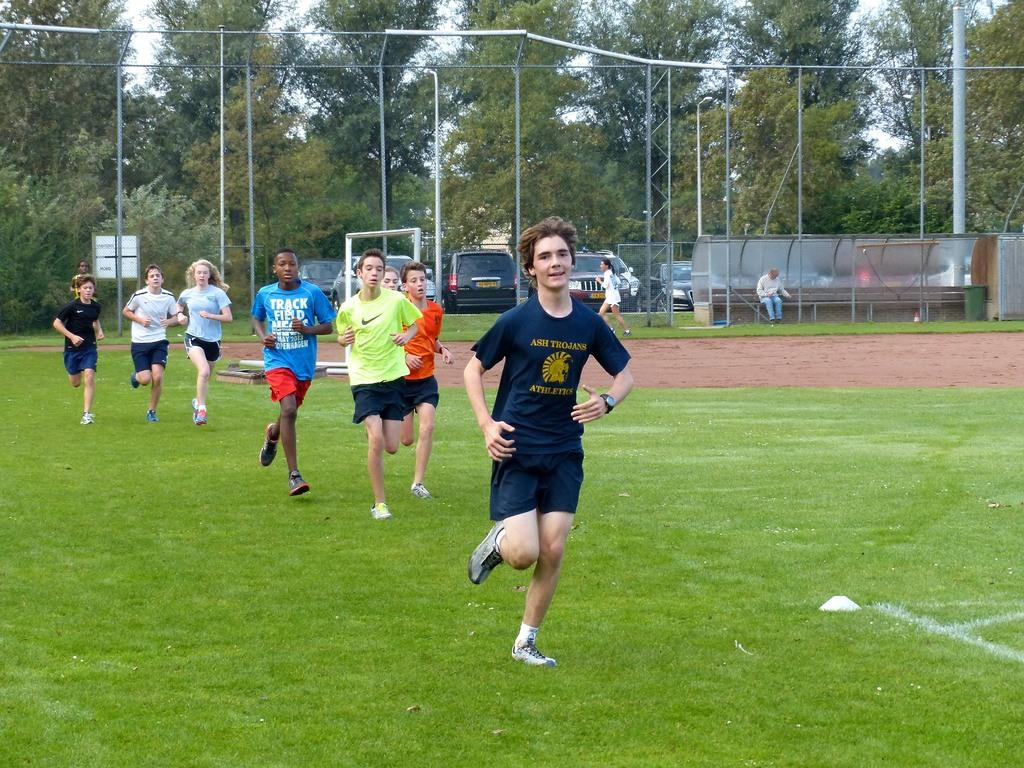Provide a one-sentence caption for the provided image. Students running on a grass field, the leader of the pack is wearing a shirt that says Ash Trojans Athletics. 